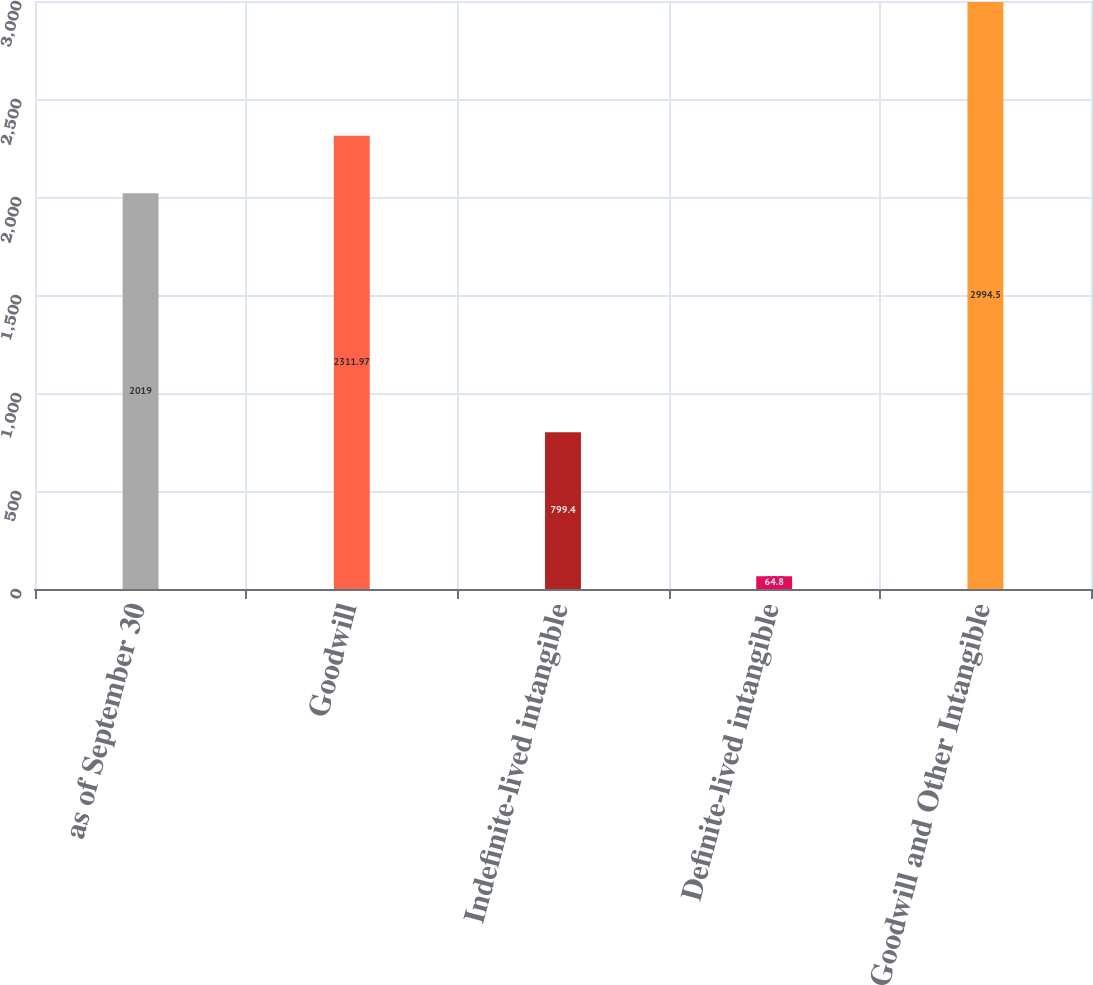<chart> <loc_0><loc_0><loc_500><loc_500><bar_chart><fcel>as of September 30<fcel>Goodwill<fcel>Indefinite-lived intangible<fcel>Definite-lived intangible<fcel>Goodwill and Other Intangible<nl><fcel>2019<fcel>2311.97<fcel>799.4<fcel>64.8<fcel>2994.5<nl></chart> 